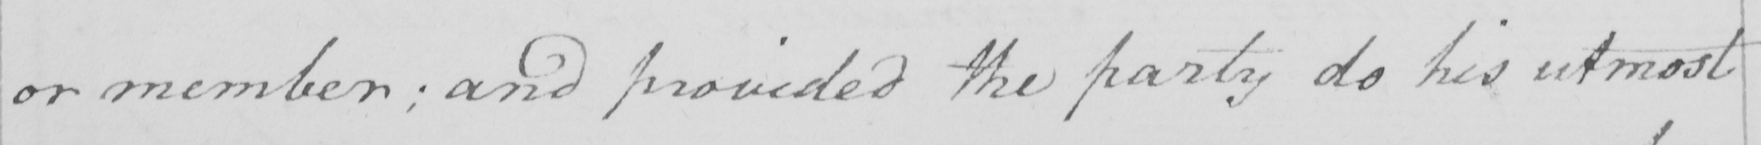Transcribe the text shown in this historical manuscript line. or member ; and provided the party do his utmost 